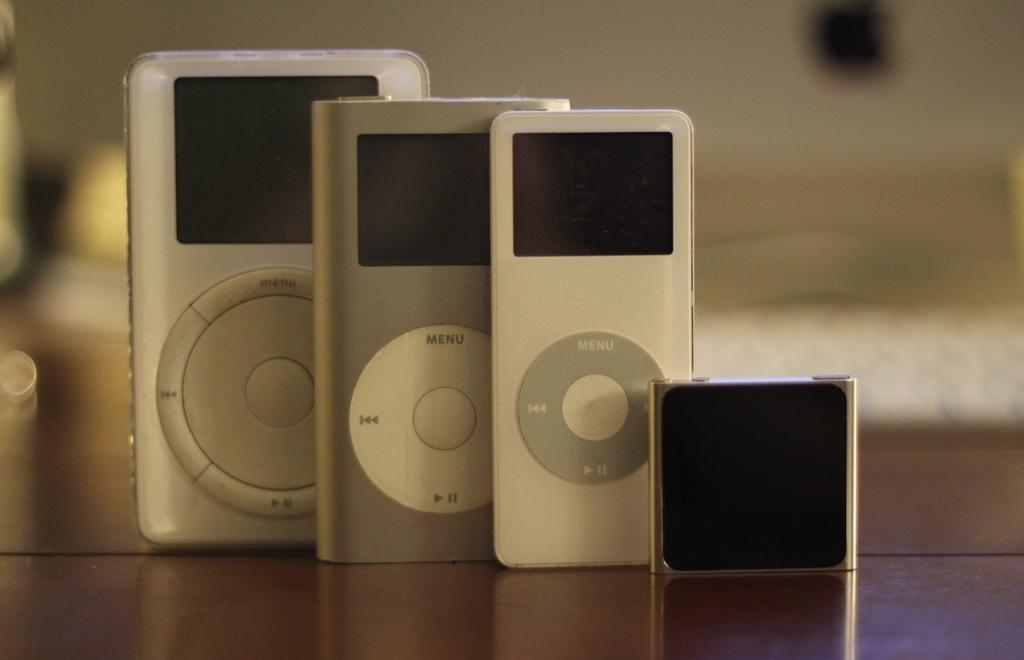<image>
Render a clear and concise summary of the photo. Three mp3 players have a menu button on the front. 